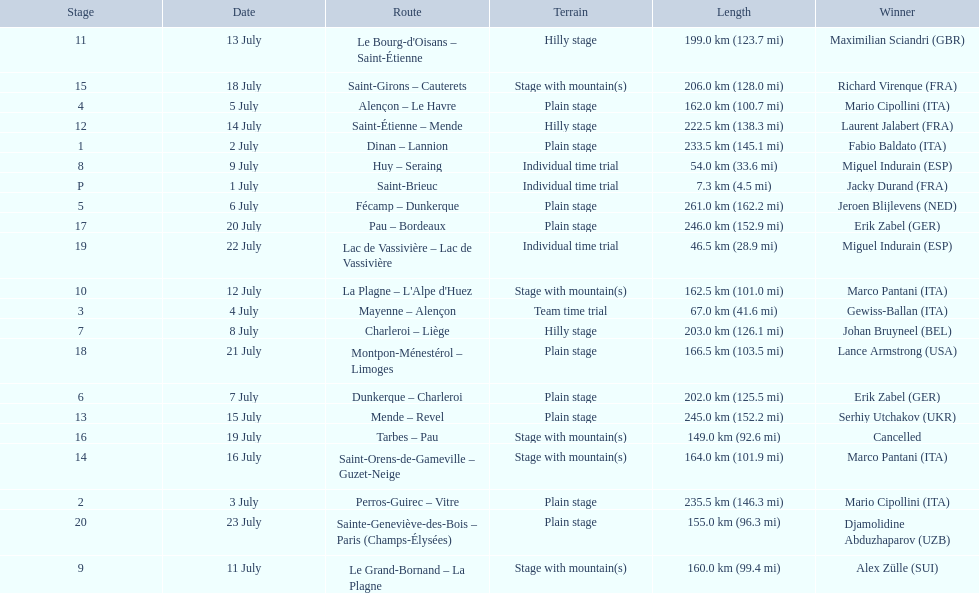What were the dates of the 1995 tour de france? 1 July, 2 July, 3 July, 4 July, 5 July, 6 July, 7 July, 8 July, 9 July, 11 July, 12 July, 13 July, 14 July, 15 July, 16 July, 18 July, 19 July, 20 July, 21 July, 22 July, 23 July. What was the length for july 8th? 203.0 km (126.1 mi). 